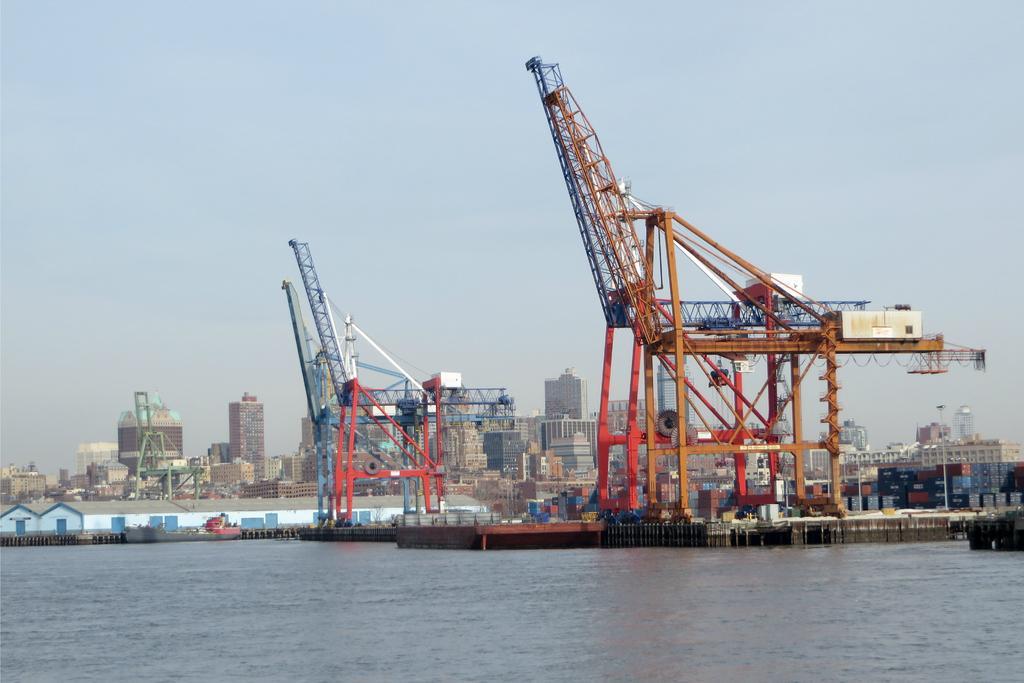How would you summarize this image in a sentence or two? In the foreground of this image, there is a port and in the background, we can see buildings and the sky. 